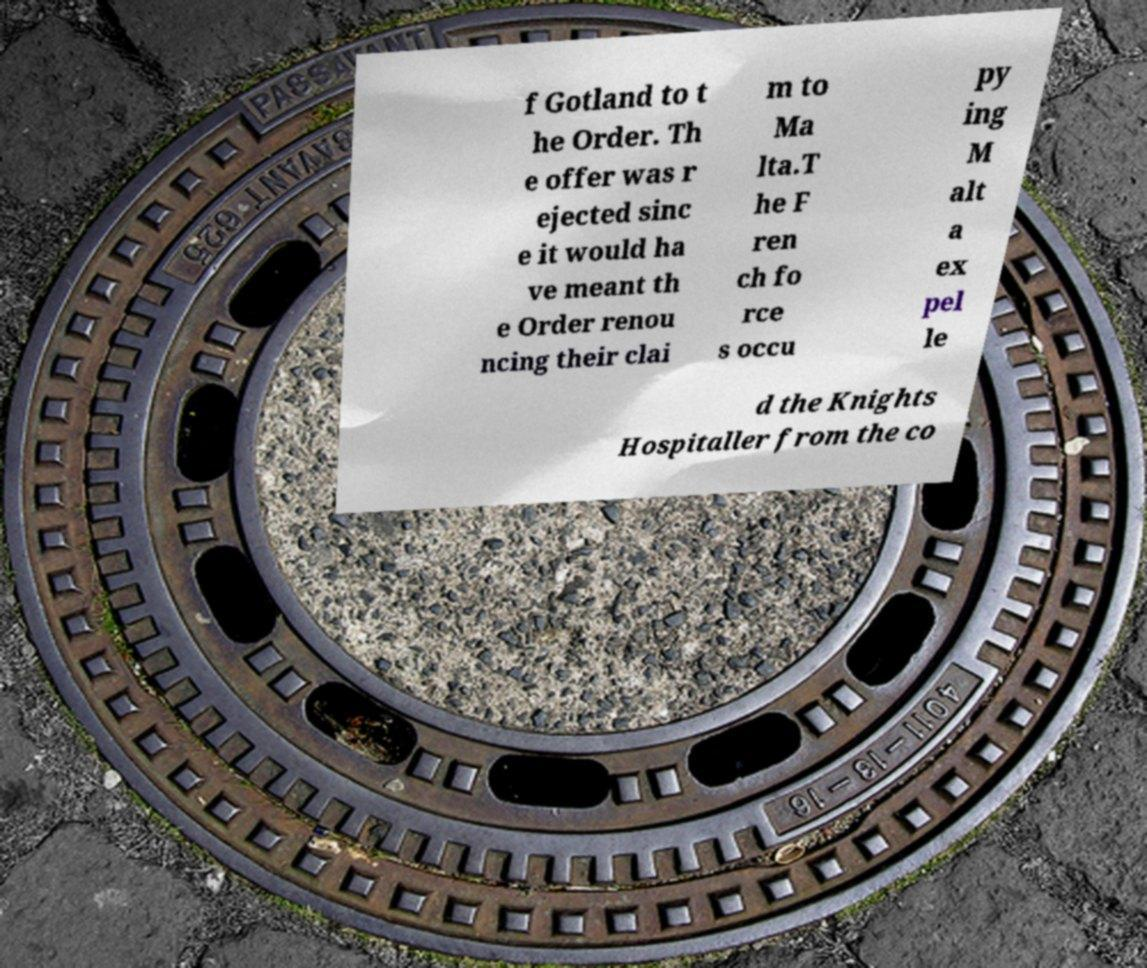Could you assist in decoding the text presented in this image and type it out clearly? f Gotland to t he Order. Th e offer was r ejected sinc e it would ha ve meant th e Order renou ncing their clai m to Ma lta.T he F ren ch fo rce s occu py ing M alt a ex pel le d the Knights Hospitaller from the co 